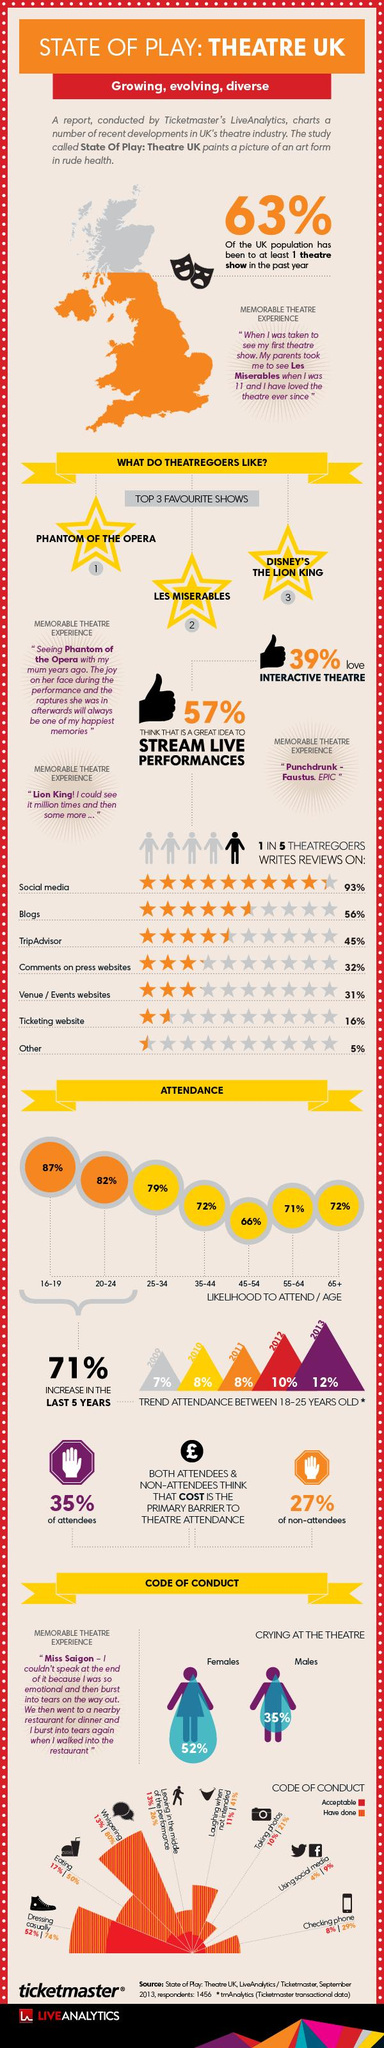Identify some key points in this picture. The platform that users typically use to write reviews after social media is blogs. In comparison to other age groups, the 45-54 age group is less likely to attend. There has been a significant increase of 71% in attendance among the 16-24 age group in the last five years. I enjoy watching "Phantom of the Opera," "Les Miserables," and "Disney's The Lion King" the most out of all the shows I have seen. The growing and evolving diversity of the world is reflected in the variety of human cultures and experiences. 